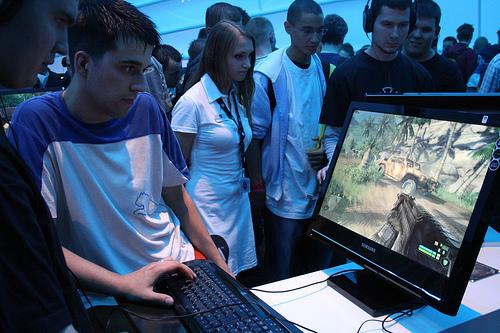Explain what the people are doing at the expo. A group of people are gathered around a computer screen, watching and participating in a video game. How are the people in the image interacting with the computer? One man is playing the game using a keyboard, while others watch and observe the computer screen. What is the primary action taking place in the image? People are watching and playing a video game on a computer screen. Identify the type of electronic device displayed in the image. Desktop computer. State the activity a woman in the image is engaged in. The woman, wearing a white dress and a badge around her neck, is standing and watching the game. What type of game is being played on the computer screen? A car racing video game. Does anyone in the image appears to be wearing any special accessories, and if so, what are they? A woman is wearing a badge around her neck, a man is wearing a gold banded wedding ring, and another man is wearing headphones. Enumerate three clothing items that are present in the image. Puma logo shirt, white dress, blue jeans. List three objects found in the image. Computer screen with a video game, man wearing headphones, woman wearing a badge around her neck. Mention a unique feature of the man playing the video game. He is wearing a gold banded wedding ring on his finger. 